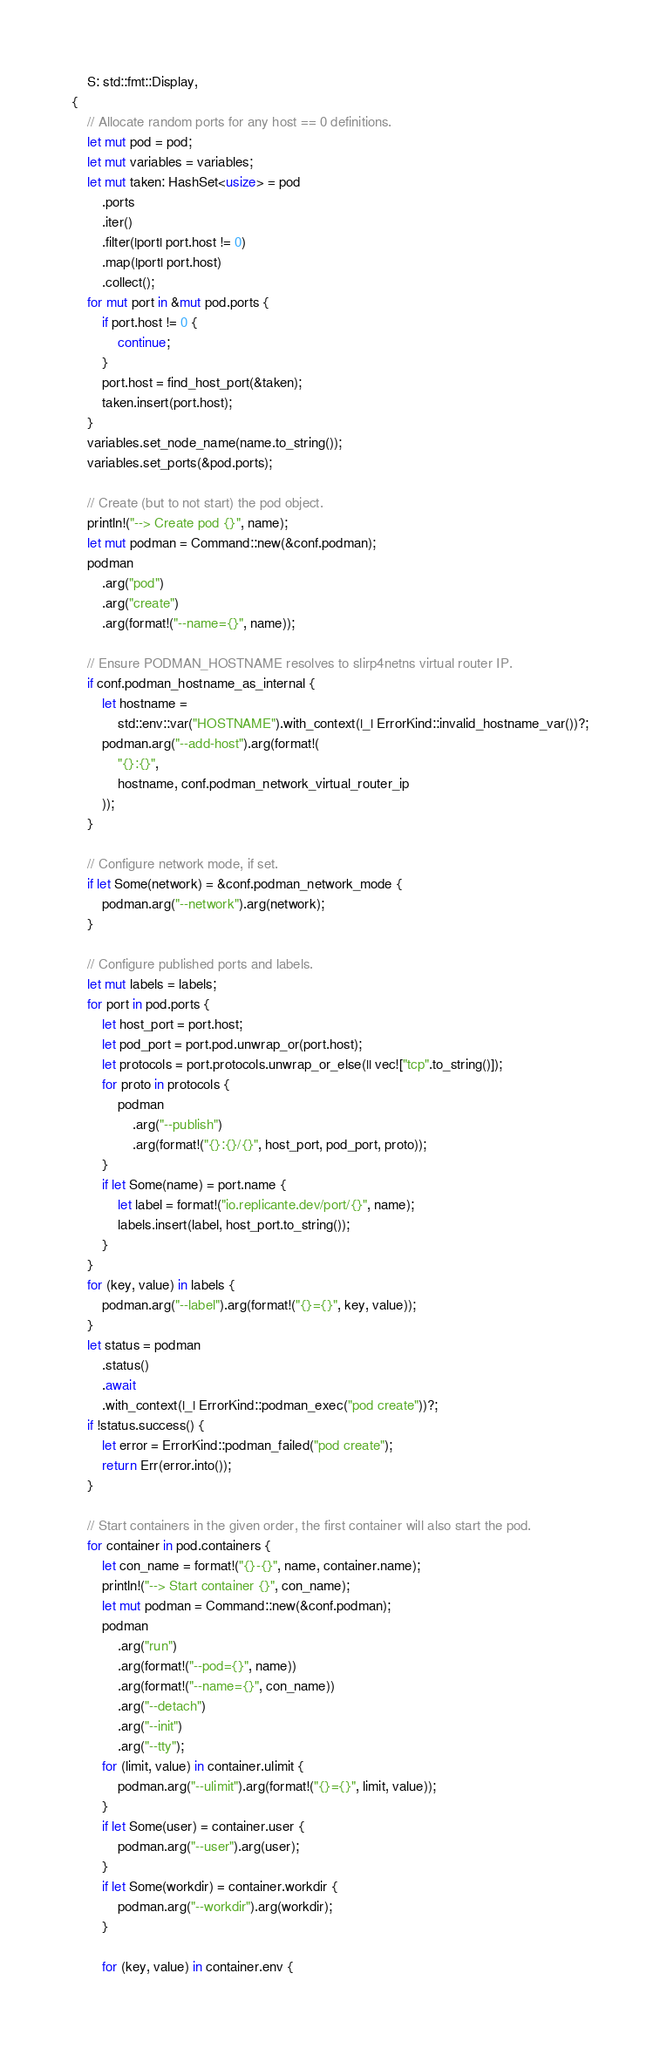<code> <loc_0><loc_0><loc_500><loc_500><_Rust_>    S: std::fmt::Display,
{
    // Allocate random ports for any host == 0 definitions.
    let mut pod = pod;
    let mut variables = variables;
    let mut taken: HashSet<usize> = pod
        .ports
        .iter()
        .filter(|port| port.host != 0)
        .map(|port| port.host)
        .collect();
    for mut port in &mut pod.ports {
        if port.host != 0 {
            continue;
        }
        port.host = find_host_port(&taken);
        taken.insert(port.host);
    }
    variables.set_node_name(name.to_string());
    variables.set_ports(&pod.ports);

    // Create (but to not start) the pod object.
    println!("--> Create pod {}", name);
    let mut podman = Command::new(&conf.podman);
    podman
        .arg("pod")
        .arg("create")
        .arg(format!("--name={}", name));

    // Ensure PODMAN_HOSTNAME resolves to slirp4netns virtual router IP.
    if conf.podman_hostname_as_internal {
        let hostname =
            std::env::var("HOSTNAME").with_context(|_| ErrorKind::invalid_hostname_var())?;
        podman.arg("--add-host").arg(format!(
            "{}:{}",
            hostname, conf.podman_network_virtual_router_ip
        ));
    }

    // Configure network mode, if set.
    if let Some(network) = &conf.podman_network_mode {
        podman.arg("--network").arg(network);
    }

    // Configure published ports and labels.
    let mut labels = labels;
    for port in pod.ports {
        let host_port = port.host;
        let pod_port = port.pod.unwrap_or(port.host);
        let protocols = port.protocols.unwrap_or_else(|| vec!["tcp".to_string()]);
        for proto in protocols {
            podman
                .arg("--publish")
                .arg(format!("{}:{}/{}", host_port, pod_port, proto));
        }
        if let Some(name) = port.name {
            let label = format!("io.replicante.dev/port/{}", name);
            labels.insert(label, host_port.to_string());
        }
    }
    for (key, value) in labels {
        podman.arg("--label").arg(format!("{}={}", key, value));
    }
    let status = podman
        .status()
        .await
        .with_context(|_| ErrorKind::podman_exec("pod create"))?;
    if !status.success() {
        let error = ErrorKind::podman_failed("pod create");
        return Err(error.into());
    }

    // Start containers in the given order, the first container will also start the pod.
    for container in pod.containers {
        let con_name = format!("{}-{}", name, container.name);
        println!("--> Start container {}", con_name);
        let mut podman = Command::new(&conf.podman);
        podman
            .arg("run")
            .arg(format!("--pod={}", name))
            .arg(format!("--name={}", con_name))
            .arg("--detach")
            .arg("--init")
            .arg("--tty");
        for (limit, value) in container.ulimit {
            podman.arg("--ulimit").arg(format!("{}={}", limit, value));
        }
        if let Some(user) = container.user {
            podman.arg("--user").arg(user);
        }
        if let Some(workdir) = container.workdir {
            podman.arg("--workdir").arg(workdir);
        }

        for (key, value) in container.env {</code> 